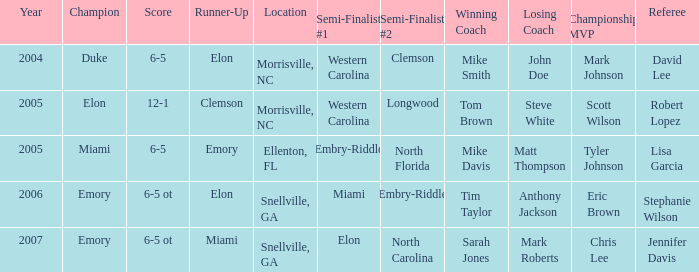Where was the final game played in 2007 Snellville, GA. 